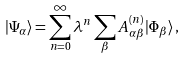Convert formula to latex. <formula><loc_0><loc_0><loc_500><loc_500>| \Psi _ { \alpha } \rangle = \sum _ { n = 0 } ^ { \infty } \lambda ^ { n } \sum _ { \beta } A ^ { ( n ) } _ { \alpha \beta } | \Phi _ { \beta } \rangle \, ,</formula> 